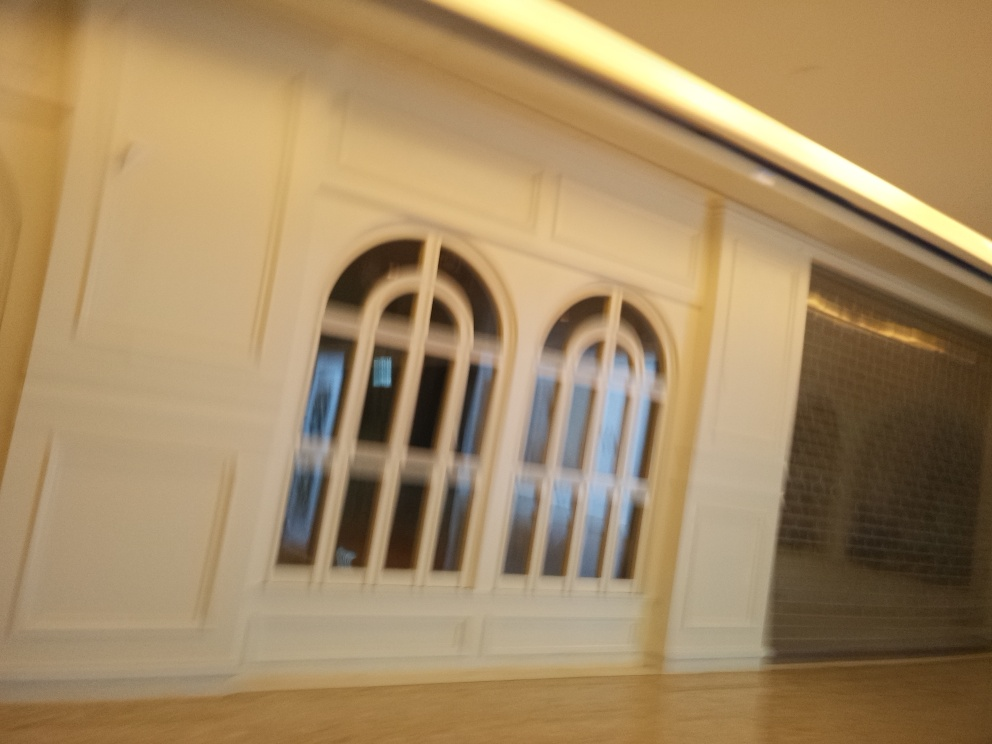What might this place be used for based on its appearance? Despite the blurriness, the visible elements of the interior — such as the large windows, the apparent spaciousness, and the refined wall detailing — suggest that this could be a public or institutional space, possibly a gallery, a hotel lobby, or an entrance hall to an elegant building. 